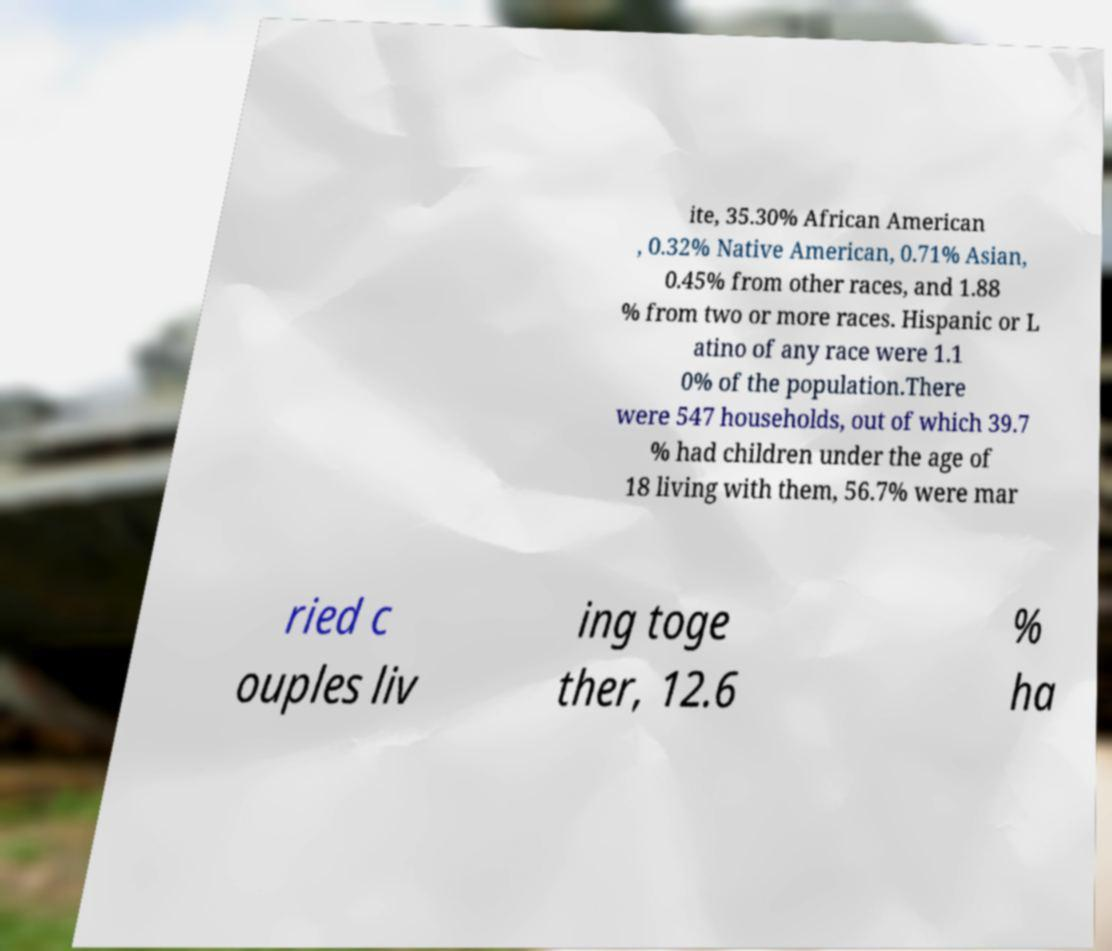I need the written content from this picture converted into text. Can you do that? ite, 35.30% African American , 0.32% Native American, 0.71% Asian, 0.45% from other races, and 1.88 % from two or more races. Hispanic or L atino of any race were 1.1 0% of the population.There were 547 households, out of which 39.7 % had children under the age of 18 living with them, 56.7% were mar ried c ouples liv ing toge ther, 12.6 % ha 